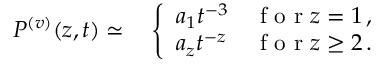<formula> <loc_0><loc_0><loc_500><loc_500>\begin{array} { r l } { P ^ { ( v ) } ( { z } , { t } ) \simeq } & \left \{ \begin{array} { l l } { a _ { 1 } t ^ { - 3 } } & { f o r z = 1 \, , } \\ { a _ { z } t ^ { - z } } & { f o r z \geq 2 \, . } \end{array} } \end{array}</formula> 